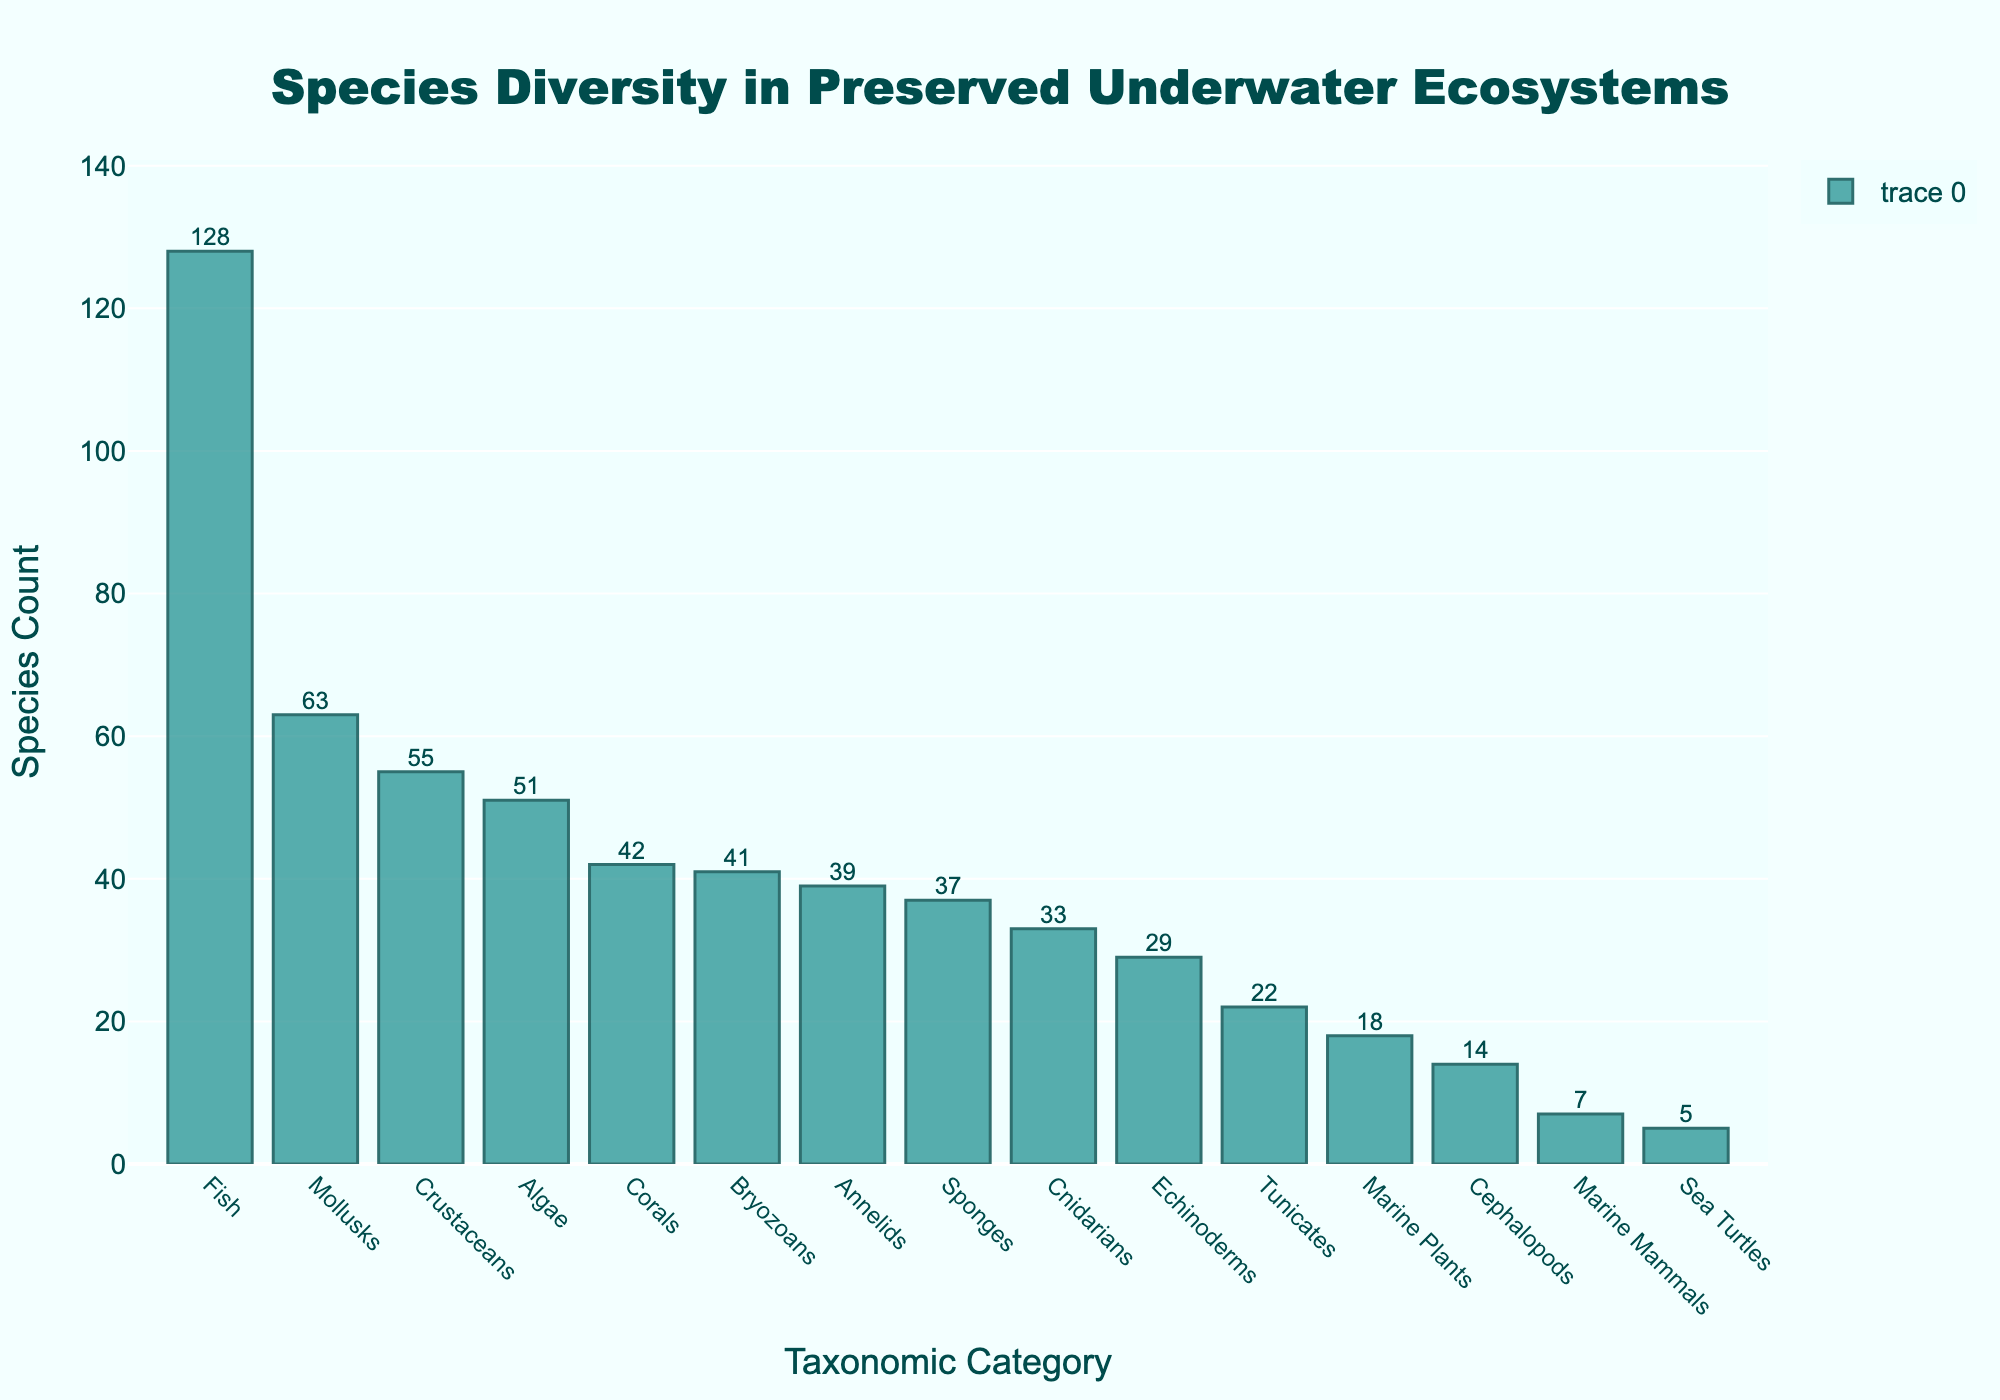What is the taxonomic category with the highest species count? The bar chart shows that the category with the highest bar corresponds to Fish.
Answer: Fish How many more species are there in the Coral category compared to the Annelids category? The bar for Corals shows 42 species, and the bar for Annelids shows 39 species. Subtracting 39 from 42 gives us 3 more species in Corals.
Answer: 3 What is the total species count of Marine Mammals, Sea Turtles, and Cephalopods combined? The Marine Mammals bar shows 7 species, Sea Turtles show 5 species, and Cephalopods show 14 species. Adding these together (7 + 5 + 14) gives a total of 26.
Answer: 26 Which taxonomic category has fewer species: Sponges or Cnidarians? Looking at the chart, Sponges have 37 species, while Cnidarians have 33 species. Since 33 < 37, Cnidarians have fewer species.
Answer: Cnidarians What is the average species count of Corals, Fish, and Mollusks? The chart displays 42 species for Corals, 128 for Fish, and 63 for Mollusks. Adding these gives 42 + 128 + 63 = 233. Dividing by 3, the average is 233 / 3 ≈ 77.67.
Answer: 77.67 Which taxonomic category is closest in species count to Algae? Algae have 51 species. The categories near 51 species are Crustaceans with 55 and Mollusks with 63. Crustaceans are closer to 51 than Mollusks.
Answer: Crustaceans By how much does the species count of Bryozoans exceed that of Tunicates? Bryozoans have 41 species and Tunicates have 22 species. Subtracting 22 from 41 gives 19.
Answer: 19 What is the combined species count of the three least diverse taxonomic categories? The least diverse categories are Sea Turtles with 5, Marine Mammals with 7, and Marine Plants with 18. Adding these (5 + 7 + 18) gives 30.
Answer: 30 Compare the heights of the bars representing Echinoderms and Annelids; which one is taller and by how much? The Annelids bar has 39 species and the Echinoderms bar has 29. Subtracting 29 from 39 gives a difference of 10, and Annelids have the taller bar.
Answer: Annelids by 10 Which taxonomic category has just slightly fewer species than Corals? The Corals bar shows 42 species. The closest smaller number is Bryozoans with 41 species.
Answer: Bryozoans 